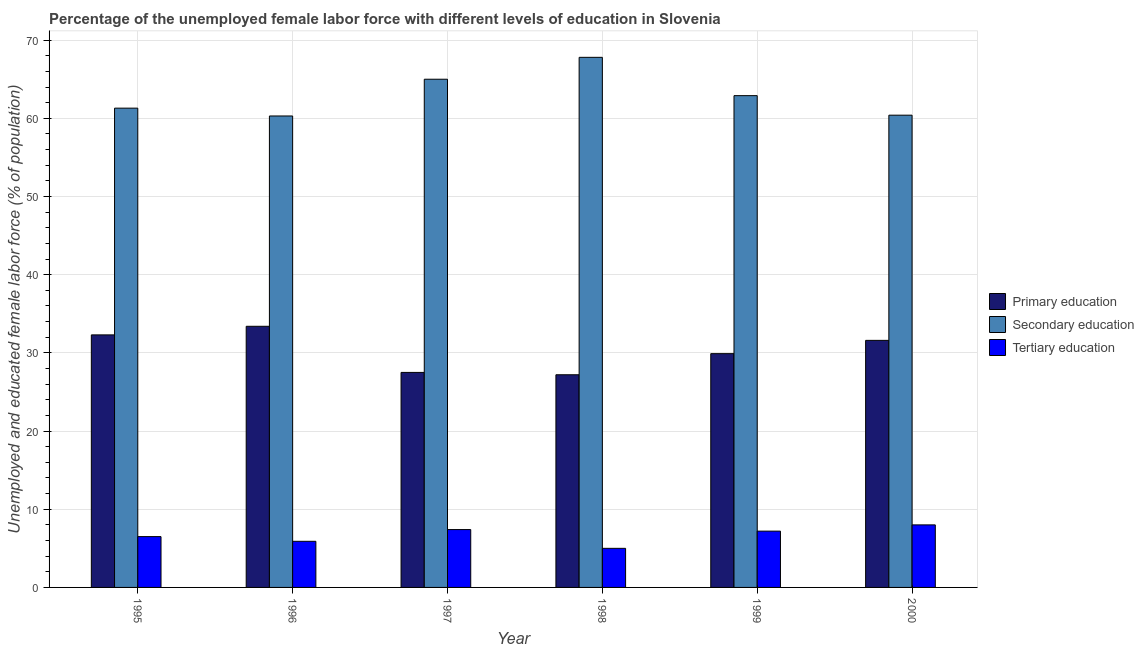What is the label of the 4th group of bars from the left?
Your answer should be compact. 1998. Across all years, what is the maximum percentage of female labor force who received secondary education?
Offer a terse response. 67.8. Across all years, what is the minimum percentage of female labor force who received primary education?
Provide a succinct answer. 27.2. What is the total percentage of female labor force who received primary education in the graph?
Make the answer very short. 181.9. What is the difference between the percentage of female labor force who received tertiary education in 1995 and that in 1998?
Provide a short and direct response. 1.5. What is the difference between the percentage of female labor force who received primary education in 1999 and the percentage of female labor force who received secondary education in 1995?
Keep it short and to the point. -2.4. What is the average percentage of female labor force who received secondary education per year?
Keep it short and to the point. 62.95. In the year 1995, what is the difference between the percentage of female labor force who received secondary education and percentage of female labor force who received tertiary education?
Give a very brief answer. 0. What is the ratio of the percentage of female labor force who received primary education in 1995 to that in 2000?
Give a very brief answer. 1.02. What is the difference between the highest and the second highest percentage of female labor force who received secondary education?
Make the answer very short. 2.8. What is the difference between the highest and the lowest percentage of female labor force who received secondary education?
Offer a very short reply. 7.5. What does the 2nd bar from the left in 1997 represents?
Give a very brief answer. Secondary education. How many years are there in the graph?
Keep it short and to the point. 6. Does the graph contain grids?
Keep it short and to the point. Yes. Where does the legend appear in the graph?
Give a very brief answer. Center right. How many legend labels are there?
Offer a very short reply. 3. What is the title of the graph?
Provide a succinct answer. Percentage of the unemployed female labor force with different levels of education in Slovenia. What is the label or title of the Y-axis?
Make the answer very short. Unemployed and educated female labor force (% of population). What is the Unemployed and educated female labor force (% of population) of Primary education in 1995?
Ensure brevity in your answer.  32.3. What is the Unemployed and educated female labor force (% of population) of Secondary education in 1995?
Provide a short and direct response. 61.3. What is the Unemployed and educated female labor force (% of population) in Tertiary education in 1995?
Your answer should be compact. 6.5. What is the Unemployed and educated female labor force (% of population) in Primary education in 1996?
Offer a very short reply. 33.4. What is the Unemployed and educated female labor force (% of population) in Secondary education in 1996?
Keep it short and to the point. 60.3. What is the Unemployed and educated female labor force (% of population) of Tertiary education in 1996?
Your answer should be compact. 5.9. What is the Unemployed and educated female labor force (% of population) in Primary education in 1997?
Keep it short and to the point. 27.5. What is the Unemployed and educated female labor force (% of population) of Secondary education in 1997?
Ensure brevity in your answer.  65. What is the Unemployed and educated female labor force (% of population) in Tertiary education in 1997?
Offer a terse response. 7.4. What is the Unemployed and educated female labor force (% of population) in Primary education in 1998?
Offer a terse response. 27.2. What is the Unemployed and educated female labor force (% of population) in Secondary education in 1998?
Keep it short and to the point. 67.8. What is the Unemployed and educated female labor force (% of population) in Tertiary education in 1998?
Give a very brief answer. 5. What is the Unemployed and educated female labor force (% of population) in Primary education in 1999?
Give a very brief answer. 29.9. What is the Unemployed and educated female labor force (% of population) in Secondary education in 1999?
Ensure brevity in your answer.  62.9. What is the Unemployed and educated female labor force (% of population) of Tertiary education in 1999?
Offer a terse response. 7.2. What is the Unemployed and educated female labor force (% of population) in Primary education in 2000?
Ensure brevity in your answer.  31.6. What is the Unemployed and educated female labor force (% of population) in Secondary education in 2000?
Ensure brevity in your answer.  60.4. Across all years, what is the maximum Unemployed and educated female labor force (% of population) in Primary education?
Your answer should be very brief. 33.4. Across all years, what is the maximum Unemployed and educated female labor force (% of population) in Secondary education?
Offer a terse response. 67.8. Across all years, what is the minimum Unemployed and educated female labor force (% of population) in Primary education?
Your response must be concise. 27.2. Across all years, what is the minimum Unemployed and educated female labor force (% of population) in Secondary education?
Provide a short and direct response. 60.3. What is the total Unemployed and educated female labor force (% of population) in Primary education in the graph?
Your answer should be very brief. 181.9. What is the total Unemployed and educated female labor force (% of population) in Secondary education in the graph?
Your answer should be very brief. 377.7. What is the total Unemployed and educated female labor force (% of population) in Tertiary education in the graph?
Your response must be concise. 40. What is the difference between the Unemployed and educated female labor force (% of population) in Tertiary education in 1995 and that in 1996?
Offer a terse response. 0.6. What is the difference between the Unemployed and educated female labor force (% of population) in Primary education in 1995 and that in 1997?
Make the answer very short. 4.8. What is the difference between the Unemployed and educated female labor force (% of population) in Secondary education in 1995 and that in 1997?
Your answer should be compact. -3.7. What is the difference between the Unemployed and educated female labor force (% of population) in Tertiary education in 1995 and that in 1997?
Give a very brief answer. -0.9. What is the difference between the Unemployed and educated female labor force (% of population) in Primary education in 1995 and that in 1999?
Provide a short and direct response. 2.4. What is the difference between the Unemployed and educated female labor force (% of population) in Secondary education in 1995 and that in 1999?
Your answer should be compact. -1.6. What is the difference between the Unemployed and educated female labor force (% of population) in Primary education in 1995 and that in 2000?
Offer a very short reply. 0.7. What is the difference between the Unemployed and educated female labor force (% of population) in Tertiary education in 1995 and that in 2000?
Make the answer very short. -1.5. What is the difference between the Unemployed and educated female labor force (% of population) of Primary education in 1996 and that in 1997?
Give a very brief answer. 5.9. What is the difference between the Unemployed and educated female labor force (% of population) in Tertiary education in 1996 and that in 1997?
Provide a short and direct response. -1.5. What is the difference between the Unemployed and educated female labor force (% of population) in Primary education in 1996 and that in 1998?
Keep it short and to the point. 6.2. What is the difference between the Unemployed and educated female labor force (% of population) of Secondary education in 1996 and that in 1999?
Keep it short and to the point. -2.6. What is the difference between the Unemployed and educated female labor force (% of population) in Secondary education in 1996 and that in 2000?
Give a very brief answer. -0.1. What is the difference between the Unemployed and educated female labor force (% of population) of Primary education in 1997 and that in 1998?
Your response must be concise. 0.3. What is the difference between the Unemployed and educated female labor force (% of population) in Secondary education in 1997 and that in 1998?
Ensure brevity in your answer.  -2.8. What is the difference between the Unemployed and educated female labor force (% of population) of Tertiary education in 1997 and that in 1998?
Provide a short and direct response. 2.4. What is the difference between the Unemployed and educated female labor force (% of population) of Secondary education in 1997 and that in 1999?
Your answer should be very brief. 2.1. What is the difference between the Unemployed and educated female labor force (% of population) of Tertiary education in 1997 and that in 1999?
Offer a very short reply. 0.2. What is the difference between the Unemployed and educated female labor force (% of population) in Primary education in 1997 and that in 2000?
Offer a very short reply. -4.1. What is the difference between the Unemployed and educated female labor force (% of population) of Secondary education in 1997 and that in 2000?
Provide a succinct answer. 4.6. What is the difference between the Unemployed and educated female labor force (% of population) in Tertiary education in 1998 and that in 2000?
Your answer should be very brief. -3. What is the difference between the Unemployed and educated female labor force (% of population) in Primary education in 1999 and that in 2000?
Offer a terse response. -1.7. What is the difference between the Unemployed and educated female labor force (% of population) of Primary education in 1995 and the Unemployed and educated female labor force (% of population) of Tertiary education in 1996?
Your answer should be very brief. 26.4. What is the difference between the Unemployed and educated female labor force (% of population) of Secondary education in 1995 and the Unemployed and educated female labor force (% of population) of Tertiary education in 1996?
Your response must be concise. 55.4. What is the difference between the Unemployed and educated female labor force (% of population) in Primary education in 1995 and the Unemployed and educated female labor force (% of population) in Secondary education in 1997?
Provide a short and direct response. -32.7. What is the difference between the Unemployed and educated female labor force (% of population) of Primary education in 1995 and the Unemployed and educated female labor force (% of population) of Tertiary education in 1997?
Your response must be concise. 24.9. What is the difference between the Unemployed and educated female labor force (% of population) in Secondary education in 1995 and the Unemployed and educated female labor force (% of population) in Tertiary education in 1997?
Your answer should be very brief. 53.9. What is the difference between the Unemployed and educated female labor force (% of population) of Primary education in 1995 and the Unemployed and educated female labor force (% of population) of Secondary education in 1998?
Provide a succinct answer. -35.5. What is the difference between the Unemployed and educated female labor force (% of population) in Primary education in 1995 and the Unemployed and educated female labor force (% of population) in Tertiary education in 1998?
Provide a short and direct response. 27.3. What is the difference between the Unemployed and educated female labor force (% of population) in Secondary education in 1995 and the Unemployed and educated female labor force (% of population) in Tertiary education in 1998?
Provide a succinct answer. 56.3. What is the difference between the Unemployed and educated female labor force (% of population) of Primary education in 1995 and the Unemployed and educated female labor force (% of population) of Secondary education in 1999?
Your answer should be compact. -30.6. What is the difference between the Unemployed and educated female labor force (% of population) in Primary education in 1995 and the Unemployed and educated female labor force (% of population) in Tertiary education in 1999?
Keep it short and to the point. 25.1. What is the difference between the Unemployed and educated female labor force (% of population) of Secondary education in 1995 and the Unemployed and educated female labor force (% of population) of Tertiary education in 1999?
Keep it short and to the point. 54.1. What is the difference between the Unemployed and educated female labor force (% of population) of Primary education in 1995 and the Unemployed and educated female labor force (% of population) of Secondary education in 2000?
Offer a very short reply. -28.1. What is the difference between the Unemployed and educated female labor force (% of population) of Primary education in 1995 and the Unemployed and educated female labor force (% of population) of Tertiary education in 2000?
Your response must be concise. 24.3. What is the difference between the Unemployed and educated female labor force (% of population) of Secondary education in 1995 and the Unemployed and educated female labor force (% of population) of Tertiary education in 2000?
Provide a short and direct response. 53.3. What is the difference between the Unemployed and educated female labor force (% of population) of Primary education in 1996 and the Unemployed and educated female labor force (% of population) of Secondary education in 1997?
Offer a terse response. -31.6. What is the difference between the Unemployed and educated female labor force (% of population) in Primary education in 1996 and the Unemployed and educated female labor force (% of population) in Tertiary education in 1997?
Your answer should be very brief. 26. What is the difference between the Unemployed and educated female labor force (% of population) of Secondary education in 1996 and the Unemployed and educated female labor force (% of population) of Tertiary education in 1997?
Offer a terse response. 52.9. What is the difference between the Unemployed and educated female labor force (% of population) in Primary education in 1996 and the Unemployed and educated female labor force (% of population) in Secondary education in 1998?
Your answer should be compact. -34.4. What is the difference between the Unemployed and educated female labor force (% of population) of Primary education in 1996 and the Unemployed and educated female labor force (% of population) of Tertiary education in 1998?
Keep it short and to the point. 28.4. What is the difference between the Unemployed and educated female labor force (% of population) of Secondary education in 1996 and the Unemployed and educated female labor force (% of population) of Tertiary education in 1998?
Give a very brief answer. 55.3. What is the difference between the Unemployed and educated female labor force (% of population) of Primary education in 1996 and the Unemployed and educated female labor force (% of population) of Secondary education in 1999?
Offer a very short reply. -29.5. What is the difference between the Unemployed and educated female labor force (% of population) in Primary education in 1996 and the Unemployed and educated female labor force (% of population) in Tertiary education in 1999?
Your response must be concise. 26.2. What is the difference between the Unemployed and educated female labor force (% of population) of Secondary education in 1996 and the Unemployed and educated female labor force (% of population) of Tertiary education in 1999?
Make the answer very short. 53.1. What is the difference between the Unemployed and educated female labor force (% of population) of Primary education in 1996 and the Unemployed and educated female labor force (% of population) of Secondary education in 2000?
Provide a succinct answer. -27. What is the difference between the Unemployed and educated female labor force (% of population) of Primary education in 1996 and the Unemployed and educated female labor force (% of population) of Tertiary education in 2000?
Make the answer very short. 25.4. What is the difference between the Unemployed and educated female labor force (% of population) in Secondary education in 1996 and the Unemployed and educated female labor force (% of population) in Tertiary education in 2000?
Make the answer very short. 52.3. What is the difference between the Unemployed and educated female labor force (% of population) in Primary education in 1997 and the Unemployed and educated female labor force (% of population) in Secondary education in 1998?
Offer a terse response. -40.3. What is the difference between the Unemployed and educated female labor force (% of population) in Primary education in 1997 and the Unemployed and educated female labor force (% of population) in Secondary education in 1999?
Give a very brief answer. -35.4. What is the difference between the Unemployed and educated female labor force (% of population) of Primary education in 1997 and the Unemployed and educated female labor force (% of population) of Tertiary education in 1999?
Keep it short and to the point. 20.3. What is the difference between the Unemployed and educated female labor force (% of population) of Secondary education in 1997 and the Unemployed and educated female labor force (% of population) of Tertiary education in 1999?
Provide a short and direct response. 57.8. What is the difference between the Unemployed and educated female labor force (% of population) of Primary education in 1997 and the Unemployed and educated female labor force (% of population) of Secondary education in 2000?
Your answer should be compact. -32.9. What is the difference between the Unemployed and educated female labor force (% of population) of Primary education in 1997 and the Unemployed and educated female labor force (% of population) of Tertiary education in 2000?
Your answer should be compact. 19.5. What is the difference between the Unemployed and educated female labor force (% of population) of Primary education in 1998 and the Unemployed and educated female labor force (% of population) of Secondary education in 1999?
Provide a short and direct response. -35.7. What is the difference between the Unemployed and educated female labor force (% of population) of Primary education in 1998 and the Unemployed and educated female labor force (% of population) of Tertiary education in 1999?
Give a very brief answer. 20. What is the difference between the Unemployed and educated female labor force (% of population) in Secondary education in 1998 and the Unemployed and educated female labor force (% of population) in Tertiary education in 1999?
Your response must be concise. 60.6. What is the difference between the Unemployed and educated female labor force (% of population) of Primary education in 1998 and the Unemployed and educated female labor force (% of population) of Secondary education in 2000?
Give a very brief answer. -33.2. What is the difference between the Unemployed and educated female labor force (% of population) of Primary education in 1998 and the Unemployed and educated female labor force (% of population) of Tertiary education in 2000?
Your answer should be compact. 19.2. What is the difference between the Unemployed and educated female labor force (% of population) in Secondary education in 1998 and the Unemployed and educated female labor force (% of population) in Tertiary education in 2000?
Keep it short and to the point. 59.8. What is the difference between the Unemployed and educated female labor force (% of population) in Primary education in 1999 and the Unemployed and educated female labor force (% of population) in Secondary education in 2000?
Your answer should be very brief. -30.5. What is the difference between the Unemployed and educated female labor force (% of population) in Primary education in 1999 and the Unemployed and educated female labor force (% of population) in Tertiary education in 2000?
Your response must be concise. 21.9. What is the difference between the Unemployed and educated female labor force (% of population) in Secondary education in 1999 and the Unemployed and educated female labor force (% of population) in Tertiary education in 2000?
Your answer should be very brief. 54.9. What is the average Unemployed and educated female labor force (% of population) in Primary education per year?
Make the answer very short. 30.32. What is the average Unemployed and educated female labor force (% of population) of Secondary education per year?
Provide a succinct answer. 62.95. What is the average Unemployed and educated female labor force (% of population) of Tertiary education per year?
Ensure brevity in your answer.  6.67. In the year 1995, what is the difference between the Unemployed and educated female labor force (% of population) of Primary education and Unemployed and educated female labor force (% of population) of Secondary education?
Provide a short and direct response. -29. In the year 1995, what is the difference between the Unemployed and educated female labor force (% of population) of Primary education and Unemployed and educated female labor force (% of population) of Tertiary education?
Make the answer very short. 25.8. In the year 1995, what is the difference between the Unemployed and educated female labor force (% of population) of Secondary education and Unemployed and educated female labor force (% of population) of Tertiary education?
Your answer should be compact. 54.8. In the year 1996, what is the difference between the Unemployed and educated female labor force (% of population) in Primary education and Unemployed and educated female labor force (% of population) in Secondary education?
Ensure brevity in your answer.  -26.9. In the year 1996, what is the difference between the Unemployed and educated female labor force (% of population) of Secondary education and Unemployed and educated female labor force (% of population) of Tertiary education?
Offer a terse response. 54.4. In the year 1997, what is the difference between the Unemployed and educated female labor force (% of population) of Primary education and Unemployed and educated female labor force (% of population) of Secondary education?
Make the answer very short. -37.5. In the year 1997, what is the difference between the Unemployed and educated female labor force (% of population) in Primary education and Unemployed and educated female labor force (% of population) in Tertiary education?
Give a very brief answer. 20.1. In the year 1997, what is the difference between the Unemployed and educated female labor force (% of population) of Secondary education and Unemployed and educated female labor force (% of population) of Tertiary education?
Keep it short and to the point. 57.6. In the year 1998, what is the difference between the Unemployed and educated female labor force (% of population) in Primary education and Unemployed and educated female labor force (% of population) in Secondary education?
Provide a short and direct response. -40.6. In the year 1998, what is the difference between the Unemployed and educated female labor force (% of population) in Secondary education and Unemployed and educated female labor force (% of population) in Tertiary education?
Provide a short and direct response. 62.8. In the year 1999, what is the difference between the Unemployed and educated female labor force (% of population) in Primary education and Unemployed and educated female labor force (% of population) in Secondary education?
Your answer should be compact. -33. In the year 1999, what is the difference between the Unemployed and educated female labor force (% of population) of Primary education and Unemployed and educated female labor force (% of population) of Tertiary education?
Keep it short and to the point. 22.7. In the year 1999, what is the difference between the Unemployed and educated female labor force (% of population) of Secondary education and Unemployed and educated female labor force (% of population) of Tertiary education?
Your answer should be very brief. 55.7. In the year 2000, what is the difference between the Unemployed and educated female labor force (% of population) of Primary education and Unemployed and educated female labor force (% of population) of Secondary education?
Offer a very short reply. -28.8. In the year 2000, what is the difference between the Unemployed and educated female labor force (% of population) in Primary education and Unemployed and educated female labor force (% of population) in Tertiary education?
Provide a succinct answer. 23.6. In the year 2000, what is the difference between the Unemployed and educated female labor force (% of population) of Secondary education and Unemployed and educated female labor force (% of population) of Tertiary education?
Give a very brief answer. 52.4. What is the ratio of the Unemployed and educated female labor force (% of population) in Primary education in 1995 to that in 1996?
Give a very brief answer. 0.97. What is the ratio of the Unemployed and educated female labor force (% of population) in Secondary education in 1995 to that in 1996?
Offer a very short reply. 1.02. What is the ratio of the Unemployed and educated female labor force (% of population) of Tertiary education in 1995 to that in 1996?
Ensure brevity in your answer.  1.1. What is the ratio of the Unemployed and educated female labor force (% of population) in Primary education in 1995 to that in 1997?
Ensure brevity in your answer.  1.17. What is the ratio of the Unemployed and educated female labor force (% of population) of Secondary education in 1995 to that in 1997?
Offer a very short reply. 0.94. What is the ratio of the Unemployed and educated female labor force (% of population) in Tertiary education in 1995 to that in 1997?
Your answer should be compact. 0.88. What is the ratio of the Unemployed and educated female labor force (% of population) in Primary education in 1995 to that in 1998?
Your response must be concise. 1.19. What is the ratio of the Unemployed and educated female labor force (% of population) of Secondary education in 1995 to that in 1998?
Your answer should be very brief. 0.9. What is the ratio of the Unemployed and educated female labor force (% of population) in Tertiary education in 1995 to that in 1998?
Offer a very short reply. 1.3. What is the ratio of the Unemployed and educated female labor force (% of population) in Primary education in 1995 to that in 1999?
Provide a short and direct response. 1.08. What is the ratio of the Unemployed and educated female labor force (% of population) in Secondary education in 1995 to that in 1999?
Offer a very short reply. 0.97. What is the ratio of the Unemployed and educated female labor force (% of population) in Tertiary education in 1995 to that in 1999?
Offer a very short reply. 0.9. What is the ratio of the Unemployed and educated female labor force (% of population) in Primary education in 1995 to that in 2000?
Provide a succinct answer. 1.02. What is the ratio of the Unemployed and educated female labor force (% of population) of Secondary education in 1995 to that in 2000?
Your answer should be compact. 1.01. What is the ratio of the Unemployed and educated female labor force (% of population) in Tertiary education in 1995 to that in 2000?
Keep it short and to the point. 0.81. What is the ratio of the Unemployed and educated female labor force (% of population) in Primary education in 1996 to that in 1997?
Make the answer very short. 1.21. What is the ratio of the Unemployed and educated female labor force (% of population) of Secondary education in 1996 to that in 1997?
Your answer should be compact. 0.93. What is the ratio of the Unemployed and educated female labor force (% of population) of Tertiary education in 1996 to that in 1997?
Give a very brief answer. 0.8. What is the ratio of the Unemployed and educated female labor force (% of population) of Primary education in 1996 to that in 1998?
Offer a very short reply. 1.23. What is the ratio of the Unemployed and educated female labor force (% of population) in Secondary education in 1996 to that in 1998?
Ensure brevity in your answer.  0.89. What is the ratio of the Unemployed and educated female labor force (% of population) in Tertiary education in 1996 to that in 1998?
Your answer should be compact. 1.18. What is the ratio of the Unemployed and educated female labor force (% of population) of Primary education in 1996 to that in 1999?
Give a very brief answer. 1.12. What is the ratio of the Unemployed and educated female labor force (% of population) of Secondary education in 1996 to that in 1999?
Your response must be concise. 0.96. What is the ratio of the Unemployed and educated female labor force (% of population) in Tertiary education in 1996 to that in 1999?
Keep it short and to the point. 0.82. What is the ratio of the Unemployed and educated female labor force (% of population) of Primary education in 1996 to that in 2000?
Your answer should be very brief. 1.06. What is the ratio of the Unemployed and educated female labor force (% of population) in Secondary education in 1996 to that in 2000?
Provide a short and direct response. 1. What is the ratio of the Unemployed and educated female labor force (% of population) in Tertiary education in 1996 to that in 2000?
Give a very brief answer. 0.74. What is the ratio of the Unemployed and educated female labor force (% of population) in Primary education in 1997 to that in 1998?
Provide a succinct answer. 1.01. What is the ratio of the Unemployed and educated female labor force (% of population) in Secondary education in 1997 to that in 1998?
Your answer should be very brief. 0.96. What is the ratio of the Unemployed and educated female labor force (% of population) in Tertiary education in 1997 to that in 1998?
Keep it short and to the point. 1.48. What is the ratio of the Unemployed and educated female labor force (% of population) of Primary education in 1997 to that in 1999?
Make the answer very short. 0.92. What is the ratio of the Unemployed and educated female labor force (% of population) of Secondary education in 1997 to that in 1999?
Your answer should be compact. 1.03. What is the ratio of the Unemployed and educated female labor force (% of population) in Tertiary education in 1997 to that in 1999?
Your answer should be compact. 1.03. What is the ratio of the Unemployed and educated female labor force (% of population) in Primary education in 1997 to that in 2000?
Your answer should be very brief. 0.87. What is the ratio of the Unemployed and educated female labor force (% of population) in Secondary education in 1997 to that in 2000?
Ensure brevity in your answer.  1.08. What is the ratio of the Unemployed and educated female labor force (% of population) in Tertiary education in 1997 to that in 2000?
Your response must be concise. 0.93. What is the ratio of the Unemployed and educated female labor force (% of population) in Primary education in 1998 to that in 1999?
Offer a terse response. 0.91. What is the ratio of the Unemployed and educated female labor force (% of population) in Secondary education in 1998 to that in 1999?
Offer a terse response. 1.08. What is the ratio of the Unemployed and educated female labor force (% of population) of Tertiary education in 1998 to that in 1999?
Make the answer very short. 0.69. What is the ratio of the Unemployed and educated female labor force (% of population) of Primary education in 1998 to that in 2000?
Your answer should be very brief. 0.86. What is the ratio of the Unemployed and educated female labor force (% of population) of Secondary education in 1998 to that in 2000?
Offer a very short reply. 1.12. What is the ratio of the Unemployed and educated female labor force (% of population) in Primary education in 1999 to that in 2000?
Provide a succinct answer. 0.95. What is the ratio of the Unemployed and educated female labor force (% of population) in Secondary education in 1999 to that in 2000?
Offer a very short reply. 1.04. What is the difference between the highest and the second highest Unemployed and educated female labor force (% of population) of Primary education?
Offer a very short reply. 1.1. What is the difference between the highest and the lowest Unemployed and educated female labor force (% of population) of Primary education?
Your answer should be compact. 6.2. What is the difference between the highest and the lowest Unemployed and educated female labor force (% of population) of Tertiary education?
Provide a short and direct response. 3. 